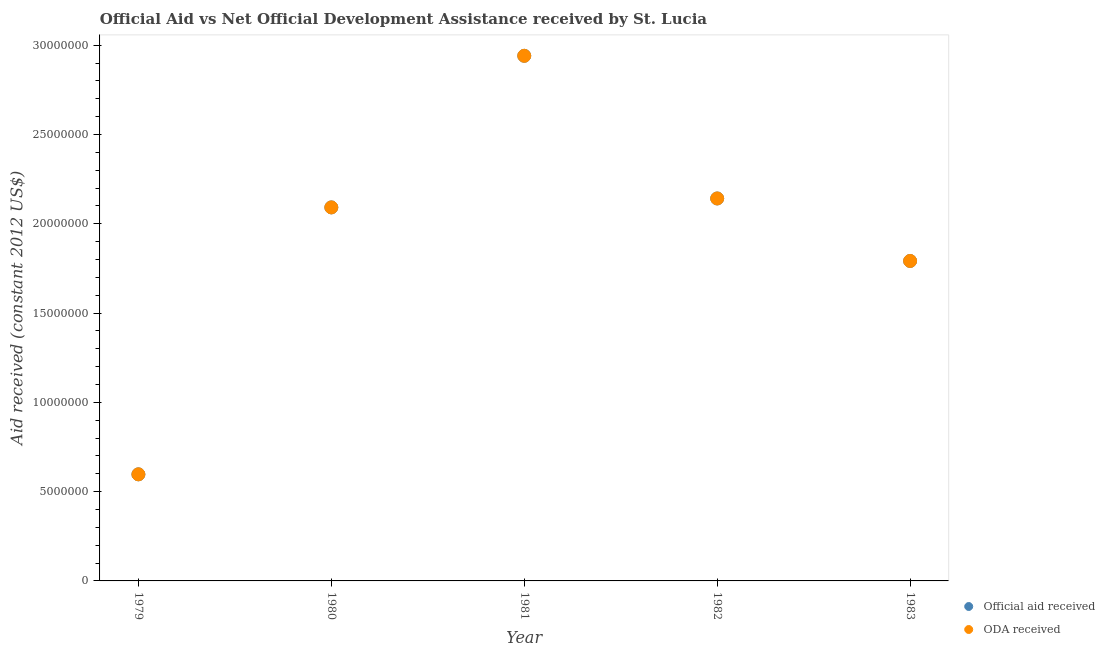How many different coloured dotlines are there?
Give a very brief answer. 2. What is the oda received in 1979?
Keep it short and to the point. 5.97e+06. Across all years, what is the maximum official aid received?
Keep it short and to the point. 2.94e+07. Across all years, what is the minimum official aid received?
Ensure brevity in your answer.  5.97e+06. In which year was the official aid received minimum?
Make the answer very short. 1979. What is the total official aid received in the graph?
Make the answer very short. 9.56e+07. What is the difference between the official aid received in 1979 and that in 1980?
Your response must be concise. -1.50e+07. What is the difference between the oda received in 1981 and the official aid received in 1980?
Your answer should be compact. 8.49e+06. What is the average oda received per year?
Your answer should be very brief. 1.91e+07. In the year 1981, what is the difference between the oda received and official aid received?
Keep it short and to the point. 0. In how many years, is the official aid received greater than 22000000 US$?
Your response must be concise. 1. What is the ratio of the official aid received in 1980 to that in 1983?
Your response must be concise. 1.17. Is the official aid received in 1981 less than that in 1983?
Your response must be concise. No. Is the difference between the official aid received in 1982 and 1983 greater than the difference between the oda received in 1982 and 1983?
Keep it short and to the point. No. What is the difference between the highest and the second highest official aid received?
Provide a succinct answer. 7.99e+06. What is the difference between the highest and the lowest official aid received?
Your answer should be very brief. 2.34e+07. Is the sum of the oda received in 1981 and 1982 greater than the maximum official aid received across all years?
Keep it short and to the point. Yes. Is the official aid received strictly greater than the oda received over the years?
Provide a succinct answer. No. Is the oda received strictly less than the official aid received over the years?
Provide a short and direct response. No. Are the values on the major ticks of Y-axis written in scientific E-notation?
Offer a very short reply. No. Does the graph contain grids?
Offer a terse response. No. How many legend labels are there?
Give a very brief answer. 2. How are the legend labels stacked?
Ensure brevity in your answer.  Vertical. What is the title of the graph?
Ensure brevity in your answer.  Official Aid vs Net Official Development Assistance received by St. Lucia . Does "Food" appear as one of the legend labels in the graph?
Provide a short and direct response. No. What is the label or title of the Y-axis?
Offer a terse response. Aid received (constant 2012 US$). What is the Aid received (constant 2012 US$) of Official aid received in 1979?
Your response must be concise. 5.97e+06. What is the Aid received (constant 2012 US$) of ODA received in 1979?
Your response must be concise. 5.97e+06. What is the Aid received (constant 2012 US$) of Official aid received in 1980?
Make the answer very short. 2.09e+07. What is the Aid received (constant 2012 US$) in ODA received in 1980?
Make the answer very short. 2.09e+07. What is the Aid received (constant 2012 US$) of Official aid received in 1981?
Give a very brief answer. 2.94e+07. What is the Aid received (constant 2012 US$) in ODA received in 1981?
Make the answer very short. 2.94e+07. What is the Aid received (constant 2012 US$) of Official aid received in 1982?
Offer a terse response. 2.14e+07. What is the Aid received (constant 2012 US$) in ODA received in 1982?
Give a very brief answer. 2.14e+07. What is the Aid received (constant 2012 US$) in Official aid received in 1983?
Ensure brevity in your answer.  1.79e+07. What is the Aid received (constant 2012 US$) of ODA received in 1983?
Offer a terse response. 1.79e+07. Across all years, what is the maximum Aid received (constant 2012 US$) in Official aid received?
Offer a very short reply. 2.94e+07. Across all years, what is the maximum Aid received (constant 2012 US$) in ODA received?
Your answer should be compact. 2.94e+07. Across all years, what is the minimum Aid received (constant 2012 US$) in Official aid received?
Provide a short and direct response. 5.97e+06. Across all years, what is the minimum Aid received (constant 2012 US$) of ODA received?
Provide a succinct answer. 5.97e+06. What is the total Aid received (constant 2012 US$) in Official aid received in the graph?
Your response must be concise. 9.56e+07. What is the total Aid received (constant 2012 US$) of ODA received in the graph?
Provide a succinct answer. 9.56e+07. What is the difference between the Aid received (constant 2012 US$) in Official aid received in 1979 and that in 1980?
Your answer should be compact. -1.50e+07. What is the difference between the Aid received (constant 2012 US$) in ODA received in 1979 and that in 1980?
Give a very brief answer. -1.50e+07. What is the difference between the Aid received (constant 2012 US$) in Official aid received in 1979 and that in 1981?
Your response must be concise. -2.34e+07. What is the difference between the Aid received (constant 2012 US$) of ODA received in 1979 and that in 1981?
Keep it short and to the point. -2.34e+07. What is the difference between the Aid received (constant 2012 US$) in Official aid received in 1979 and that in 1982?
Your answer should be compact. -1.54e+07. What is the difference between the Aid received (constant 2012 US$) of ODA received in 1979 and that in 1982?
Keep it short and to the point. -1.54e+07. What is the difference between the Aid received (constant 2012 US$) in Official aid received in 1979 and that in 1983?
Your answer should be very brief. -1.20e+07. What is the difference between the Aid received (constant 2012 US$) in ODA received in 1979 and that in 1983?
Your answer should be very brief. -1.20e+07. What is the difference between the Aid received (constant 2012 US$) of Official aid received in 1980 and that in 1981?
Make the answer very short. -8.49e+06. What is the difference between the Aid received (constant 2012 US$) of ODA received in 1980 and that in 1981?
Ensure brevity in your answer.  -8.49e+06. What is the difference between the Aid received (constant 2012 US$) in Official aid received in 1980 and that in 1982?
Offer a very short reply. -5.00e+05. What is the difference between the Aid received (constant 2012 US$) in ODA received in 1980 and that in 1982?
Make the answer very short. -5.00e+05. What is the difference between the Aid received (constant 2012 US$) of ODA received in 1980 and that in 1983?
Provide a succinct answer. 3.00e+06. What is the difference between the Aid received (constant 2012 US$) of Official aid received in 1981 and that in 1982?
Ensure brevity in your answer.  7.99e+06. What is the difference between the Aid received (constant 2012 US$) of ODA received in 1981 and that in 1982?
Give a very brief answer. 7.99e+06. What is the difference between the Aid received (constant 2012 US$) in Official aid received in 1981 and that in 1983?
Give a very brief answer. 1.15e+07. What is the difference between the Aid received (constant 2012 US$) in ODA received in 1981 and that in 1983?
Your response must be concise. 1.15e+07. What is the difference between the Aid received (constant 2012 US$) in Official aid received in 1982 and that in 1983?
Make the answer very short. 3.50e+06. What is the difference between the Aid received (constant 2012 US$) of ODA received in 1982 and that in 1983?
Your answer should be very brief. 3.50e+06. What is the difference between the Aid received (constant 2012 US$) of Official aid received in 1979 and the Aid received (constant 2012 US$) of ODA received in 1980?
Your answer should be compact. -1.50e+07. What is the difference between the Aid received (constant 2012 US$) of Official aid received in 1979 and the Aid received (constant 2012 US$) of ODA received in 1981?
Your answer should be very brief. -2.34e+07. What is the difference between the Aid received (constant 2012 US$) in Official aid received in 1979 and the Aid received (constant 2012 US$) in ODA received in 1982?
Provide a succinct answer. -1.54e+07. What is the difference between the Aid received (constant 2012 US$) of Official aid received in 1979 and the Aid received (constant 2012 US$) of ODA received in 1983?
Provide a short and direct response. -1.20e+07. What is the difference between the Aid received (constant 2012 US$) in Official aid received in 1980 and the Aid received (constant 2012 US$) in ODA received in 1981?
Provide a succinct answer. -8.49e+06. What is the difference between the Aid received (constant 2012 US$) of Official aid received in 1980 and the Aid received (constant 2012 US$) of ODA received in 1982?
Your response must be concise. -5.00e+05. What is the difference between the Aid received (constant 2012 US$) in Official aid received in 1981 and the Aid received (constant 2012 US$) in ODA received in 1982?
Keep it short and to the point. 7.99e+06. What is the difference between the Aid received (constant 2012 US$) of Official aid received in 1981 and the Aid received (constant 2012 US$) of ODA received in 1983?
Your response must be concise. 1.15e+07. What is the difference between the Aid received (constant 2012 US$) of Official aid received in 1982 and the Aid received (constant 2012 US$) of ODA received in 1983?
Your answer should be compact. 3.50e+06. What is the average Aid received (constant 2012 US$) in Official aid received per year?
Provide a succinct answer. 1.91e+07. What is the average Aid received (constant 2012 US$) in ODA received per year?
Your answer should be compact. 1.91e+07. In the year 1979, what is the difference between the Aid received (constant 2012 US$) in Official aid received and Aid received (constant 2012 US$) in ODA received?
Offer a very short reply. 0. In the year 1980, what is the difference between the Aid received (constant 2012 US$) of Official aid received and Aid received (constant 2012 US$) of ODA received?
Your response must be concise. 0. In the year 1981, what is the difference between the Aid received (constant 2012 US$) in Official aid received and Aid received (constant 2012 US$) in ODA received?
Your answer should be very brief. 0. In the year 1982, what is the difference between the Aid received (constant 2012 US$) in Official aid received and Aid received (constant 2012 US$) in ODA received?
Your answer should be compact. 0. What is the ratio of the Aid received (constant 2012 US$) in Official aid received in 1979 to that in 1980?
Provide a short and direct response. 0.29. What is the ratio of the Aid received (constant 2012 US$) in ODA received in 1979 to that in 1980?
Offer a very short reply. 0.29. What is the ratio of the Aid received (constant 2012 US$) of Official aid received in 1979 to that in 1981?
Give a very brief answer. 0.2. What is the ratio of the Aid received (constant 2012 US$) in ODA received in 1979 to that in 1981?
Offer a very short reply. 0.2. What is the ratio of the Aid received (constant 2012 US$) of Official aid received in 1979 to that in 1982?
Provide a succinct answer. 0.28. What is the ratio of the Aid received (constant 2012 US$) of ODA received in 1979 to that in 1982?
Offer a terse response. 0.28. What is the ratio of the Aid received (constant 2012 US$) of Official aid received in 1979 to that in 1983?
Ensure brevity in your answer.  0.33. What is the ratio of the Aid received (constant 2012 US$) of ODA received in 1979 to that in 1983?
Your response must be concise. 0.33. What is the ratio of the Aid received (constant 2012 US$) in Official aid received in 1980 to that in 1981?
Give a very brief answer. 0.71. What is the ratio of the Aid received (constant 2012 US$) in ODA received in 1980 to that in 1981?
Provide a succinct answer. 0.71. What is the ratio of the Aid received (constant 2012 US$) in Official aid received in 1980 to that in 1982?
Offer a very short reply. 0.98. What is the ratio of the Aid received (constant 2012 US$) of ODA received in 1980 to that in 1982?
Your response must be concise. 0.98. What is the ratio of the Aid received (constant 2012 US$) of Official aid received in 1980 to that in 1983?
Keep it short and to the point. 1.17. What is the ratio of the Aid received (constant 2012 US$) of ODA received in 1980 to that in 1983?
Ensure brevity in your answer.  1.17. What is the ratio of the Aid received (constant 2012 US$) in Official aid received in 1981 to that in 1982?
Provide a succinct answer. 1.37. What is the ratio of the Aid received (constant 2012 US$) in ODA received in 1981 to that in 1982?
Your response must be concise. 1.37. What is the ratio of the Aid received (constant 2012 US$) of Official aid received in 1981 to that in 1983?
Keep it short and to the point. 1.64. What is the ratio of the Aid received (constant 2012 US$) of ODA received in 1981 to that in 1983?
Your answer should be very brief. 1.64. What is the ratio of the Aid received (constant 2012 US$) in Official aid received in 1982 to that in 1983?
Your answer should be very brief. 1.2. What is the ratio of the Aid received (constant 2012 US$) of ODA received in 1982 to that in 1983?
Your response must be concise. 1.2. What is the difference between the highest and the second highest Aid received (constant 2012 US$) in Official aid received?
Offer a very short reply. 7.99e+06. What is the difference between the highest and the second highest Aid received (constant 2012 US$) of ODA received?
Provide a short and direct response. 7.99e+06. What is the difference between the highest and the lowest Aid received (constant 2012 US$) in Official aid received?
Your response must be concise. 2.34e+07. What is the difference between the highest and the lowest Aid received (constant 2012 US$) in ODA received?
Offer a terse response. 2.34e+07. 